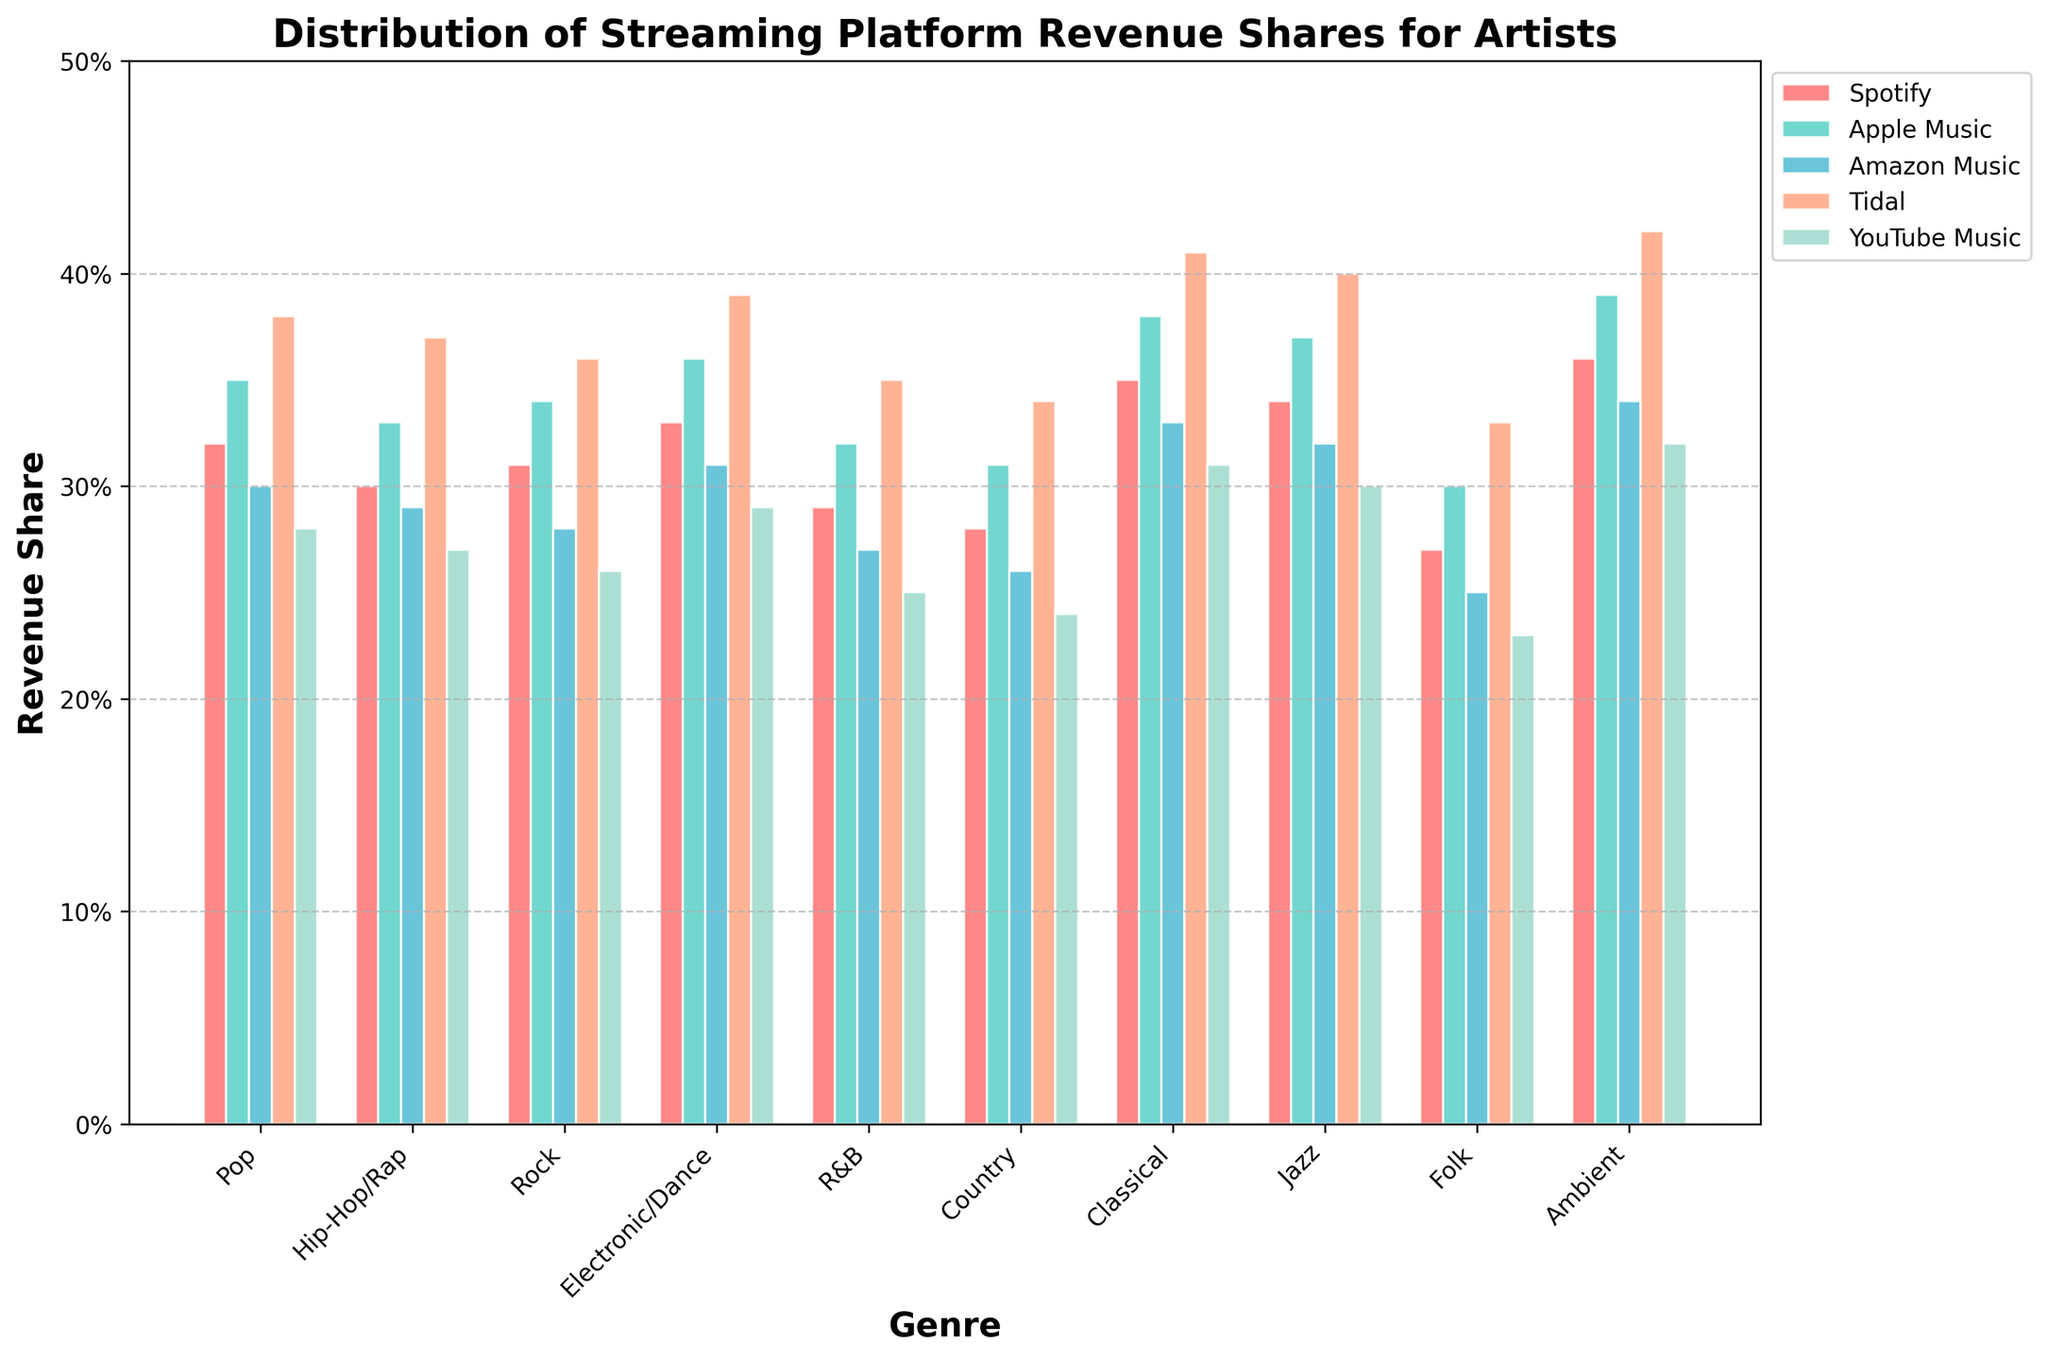What music genre has the highest revenue share for Tidal? To find the genre with the highest revenue share for Tidal, look for the tallest green bar among all the genres. The highest green bar is for the Ambient genre, indicating that Ambient has the highest revenue share on Tidal.
Answer: Ambient Which streaming platform provides the lowest revenue share for Classical music? Analyze the bars representing Classical music and identify which one is the shortest among them. The shortest bar for Classical music belongs to YouTube Music.
Answer: YouTube Music Which genre has a more significant revenue share on Spotify: Pop or Country? Compare the heights of the red bars for Pop and Country genres. The red bar for Pop is taller than that for Country, indicating that Pop has a higher revenue share on Spotify than Country.
Answer: Pop What is the average revenue share for Hip-Hop/Rap across all platforms? To determine the average revenue share for Hip-Hop/Rap, sum the revenue shares for Spotify (0.30), Apple Music (0.33), Amazon Music (0.29), Tidal (0.37), and YouTube Music (0.27). Then, divide the total by 5:
(0.30 + 0.33 + 0.29 + 0.37 + 0.27) / 5 = 1.56 / 5 = 0.312
Answer: 0.312 By how much does Tidal's revenue share for Electronic/Dance exceed that of YouTube Music? Identify and subtract the revenue shares from Tidal and YouTube Music for Electronic/Dance. Tidal has 0.39 and YouTube Music has 0.29, so 0.39 - 0.29 = 0.10
Answer: 0.10 Is Jazz revenue share higher on Apple Music or Amazon Music? Compare the heights of the bars representing Jazz for Apple Music and Amazon Music. The bar for Jazz on Apple Music is taller, indicating a higher revenue share on Apple Music than Amazon Music.
Answer: Apple Music For Electronic/Dance, which platform has the second-highest revenue share? Order the bars for Electronic/Dance in descending order to identify the second highest. The highest is Tidal (0.39) and the second highest is Apple Music (0.36).
Answer: Apple Music Are there any genres where Spotify provides the highest revenue share among all platforms? Analyze if any of the highest revenue shares across all platforms (the tallest bar per genre) corresponds to Spotify (red bars). None of the genres has Spotify as the highest revenue share.
Answer: No 